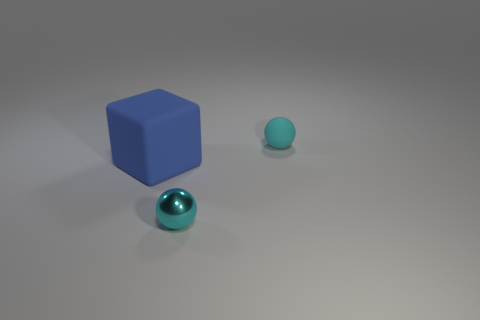There is a thing that is in front of the blue block; how many tiny matte balls are behind it? Behind the blue block, there appears to be just one tiny matte ball, exhibiting a subtle sheen under the ambient lighting. 